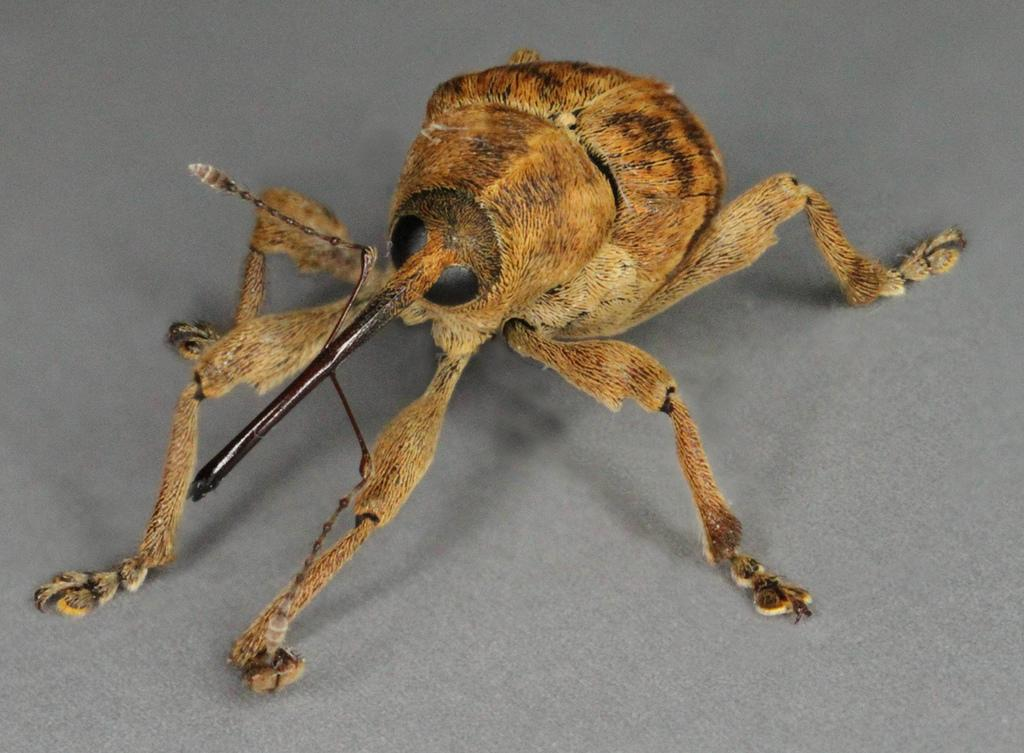What type of creature can be seen in the image? There is an insect in the image. What is the insect resting on? The insect is on a grey color surface. How many heads of cattle can be seen grazing on the cabbage in the image? There are no cattle or cabbage present in the image; it features an insect on a grey color surface. 